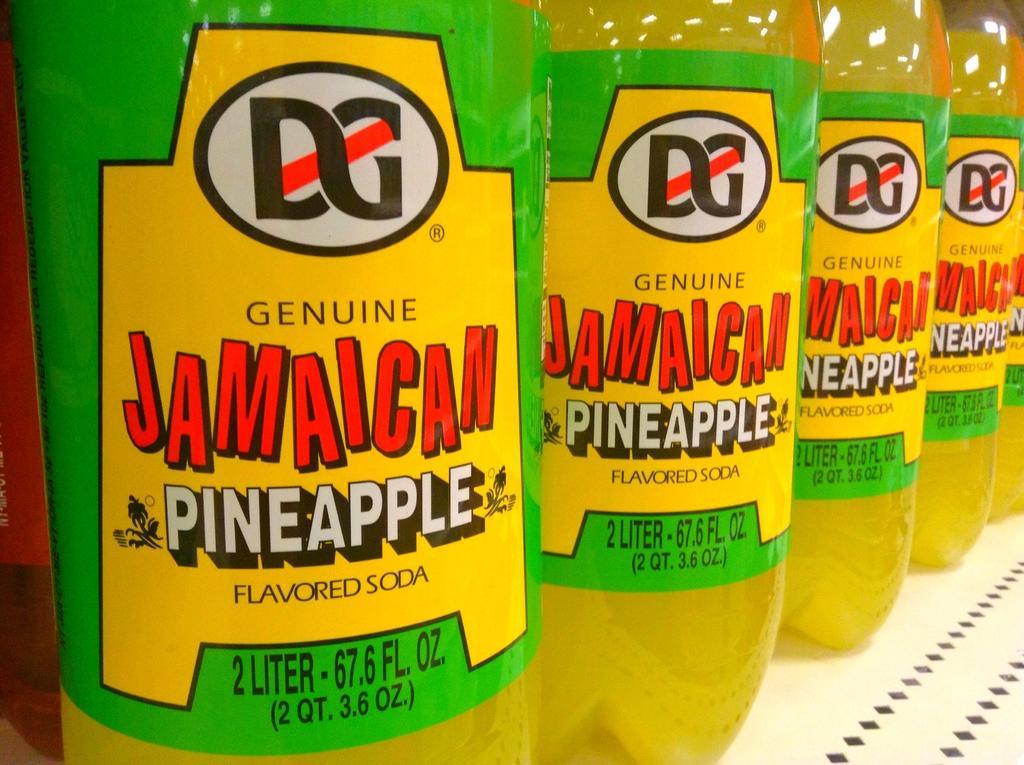Can you describe this image briefly? This picture shows a pineapple flavored soda bottles, arranged in a shelf here. 